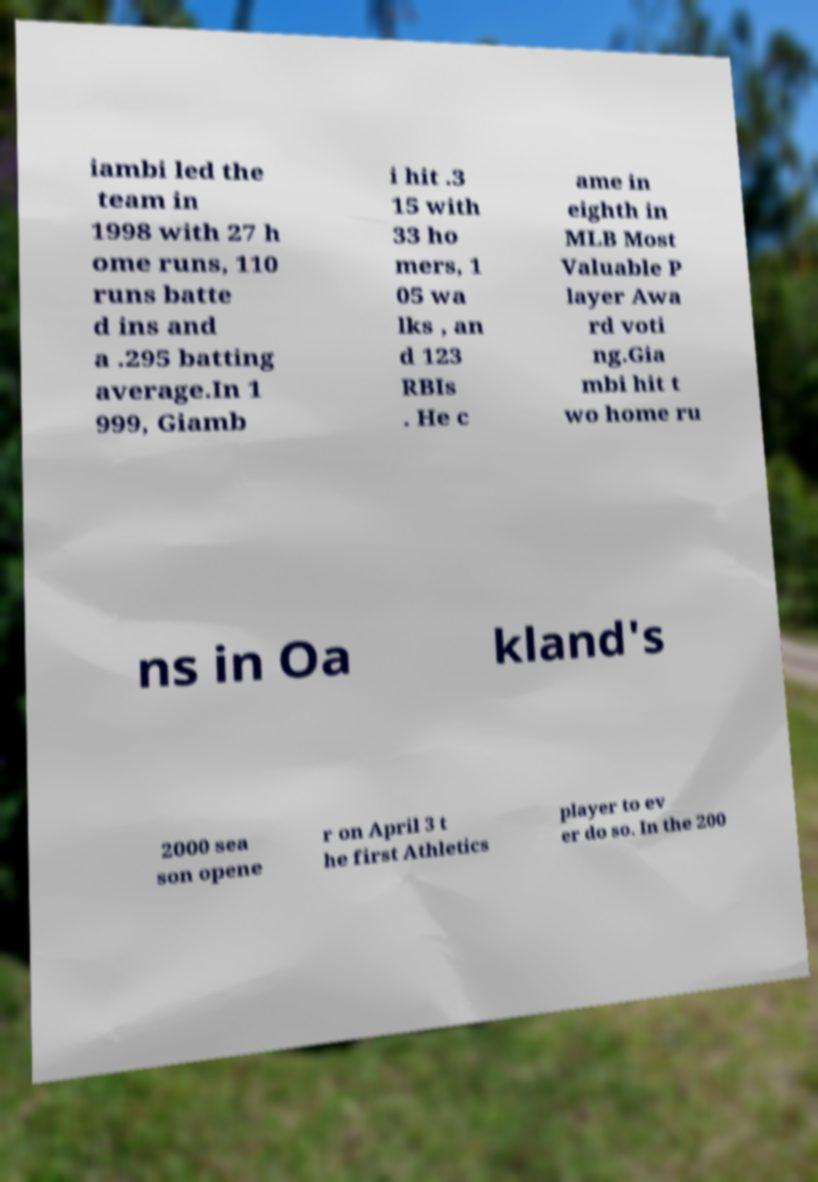Can you read and provide the text displayed in the image?This photo seems to have some interesting text. Can you extract and type it out for me? iambi led the team in 1998 with 27 h ome runs, 110 runs batte d ins and a .295 batting average.In 1 999, Giamb i hit .3 15 with 33 ho mers, 1 05 wa lks , an d 123 RBIs . He c ame in eighth in MLB Most Valuable P layer Awa rd voti ng.Gia mbi hit t wo home ru ns in Oa kland's 2000 sea son opene r on April 3 t he first Athletics player to ev er do so. In the 200 